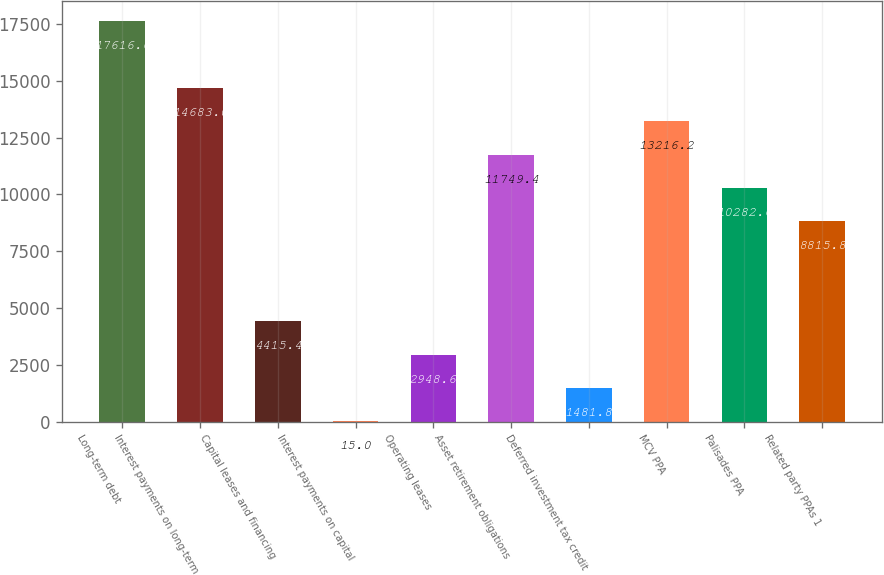<chart> <loc_0><loc_0><loc_500><loc_500><bar_chart><fcel>Long-term debt<fcel>Interest payments on long-term<fcel>Capital leases and financing<fcel>Interest payments on capital<fcel>Operating leases<fcel>Asset retirement obligations<fcel>Deferred investment tax credit<fcel>MCV PPA<fcel>Palisades PPA<fcel>Related party PPAs 1<nl><fcel>17616.6<fcel>14683<fcel>4415.4<fcel>15<fcel>2948.6<fcel>11749.4<fcel>1481.8<fcel>13216.2<fcel>10282.6<fcel>8815.8<nl></chart> 